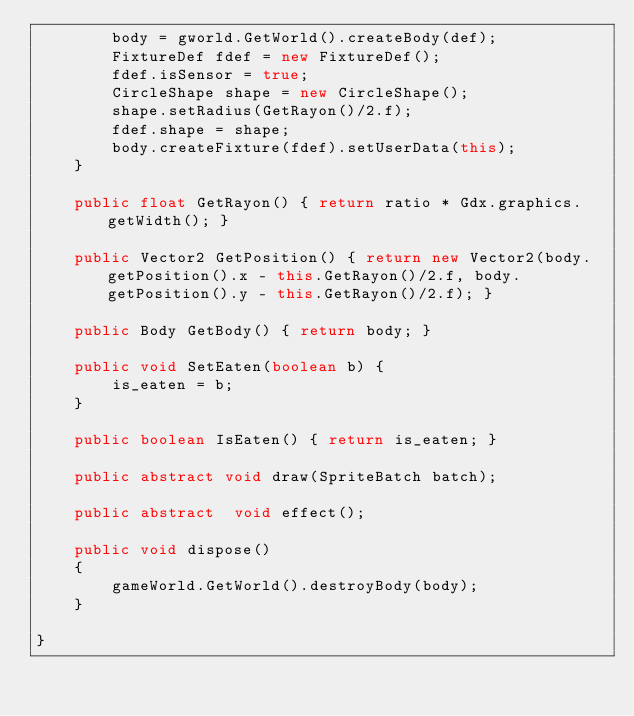<code> <loc_0><loc_0><loc_500><loc_500><_Java_>        body = gworld.GetWorld().createBody(def);
        FixtureDef fdef = new FixtureDef();
        fdef.isSensor = true;
        CircleShape shape = new CircleShape();
        shape.setRadius(GetRayon()/2.f);
        fdef.shape = shape;
        body.createFixture(fdef).setUserData(this);
    }

    public float GetRayon() { return ratio * Gdx.graphics.getWidth(); }

    public Vector2 GetPosition() { return new Vector2(body.getPosition().x - this.GetRayon()/2.f, body.getPosition().y - this.GetRayon()/2.f); }

    public Body GetBody() { return body; }

    public void SetEaten(boolean b) {
        is_eaten = b;
    }

    public boolean IsEaten() { return is_eaten; }

    public abstract void draw(SpriteBatch batch);

    public abstract  void effect();

    public void dispose()
    {
        gameWorld.GetWorld().destroyBody(body);
    }

}
</code> 